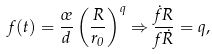<formula> <loc_0><loc_0><loc_500><loc_500>f ( t ) = \frac { \sigma } { d } \left ( \frac { R } { r _ { 0 } } \right ) ^ { q } \Rightarrow \frac { \dot { f } R } { f \dot { R } } = q ,</formula> 